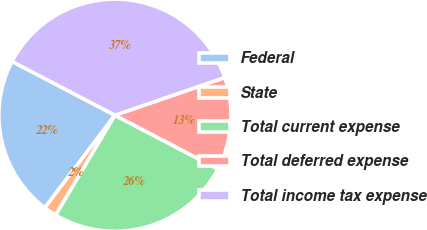<chart> <loc_0><loc_0><loc_500><loc_500><pie_chart><fcel>Federal<fcel>State<fcel>Total current expense<fcel>Total deferred expense<fcel>Total income tax expense<nl><fcel>22.34%<fcel>1.8%<fcel>25.86%<fcel>12.93%<fcel>37.07%<nl></chart> 